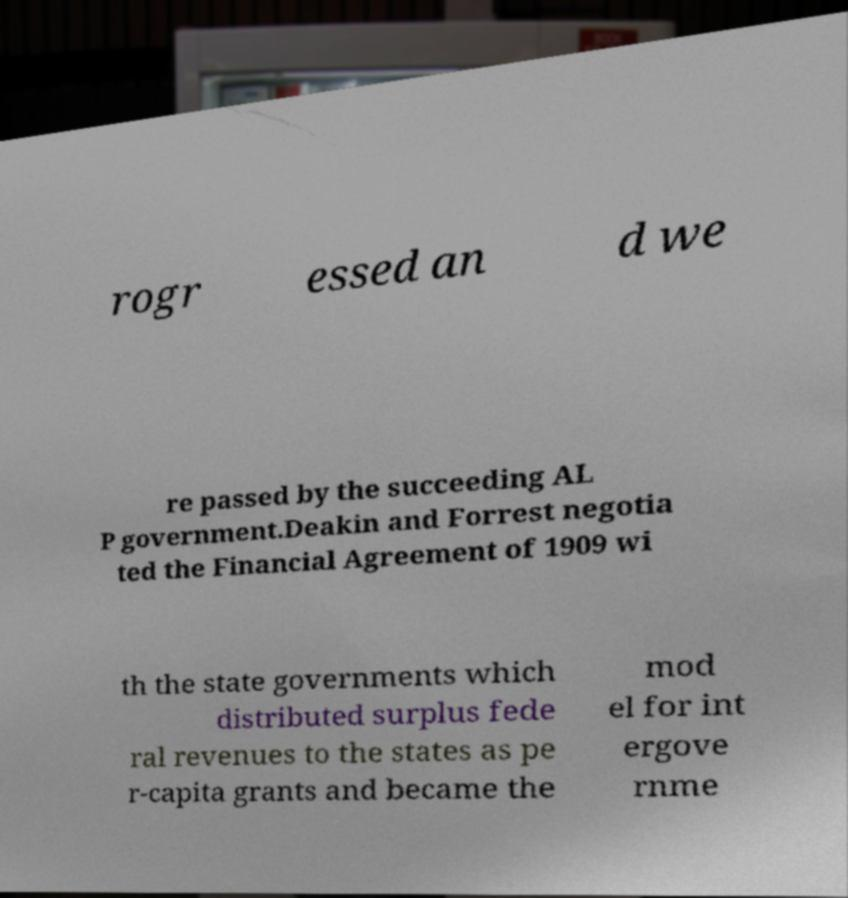There's text embedded in this image that I need extracted. Can you transcribe it verbatim? rogr essed an d we re passed by the succeeding AL P government.Deakin and Forrest negotia ted the Financial Agreement of 1909 wi th the state governments which distributed surplus fede ral revenues to the states as pe r-capita grants and became the mod el for int ergove rnme 